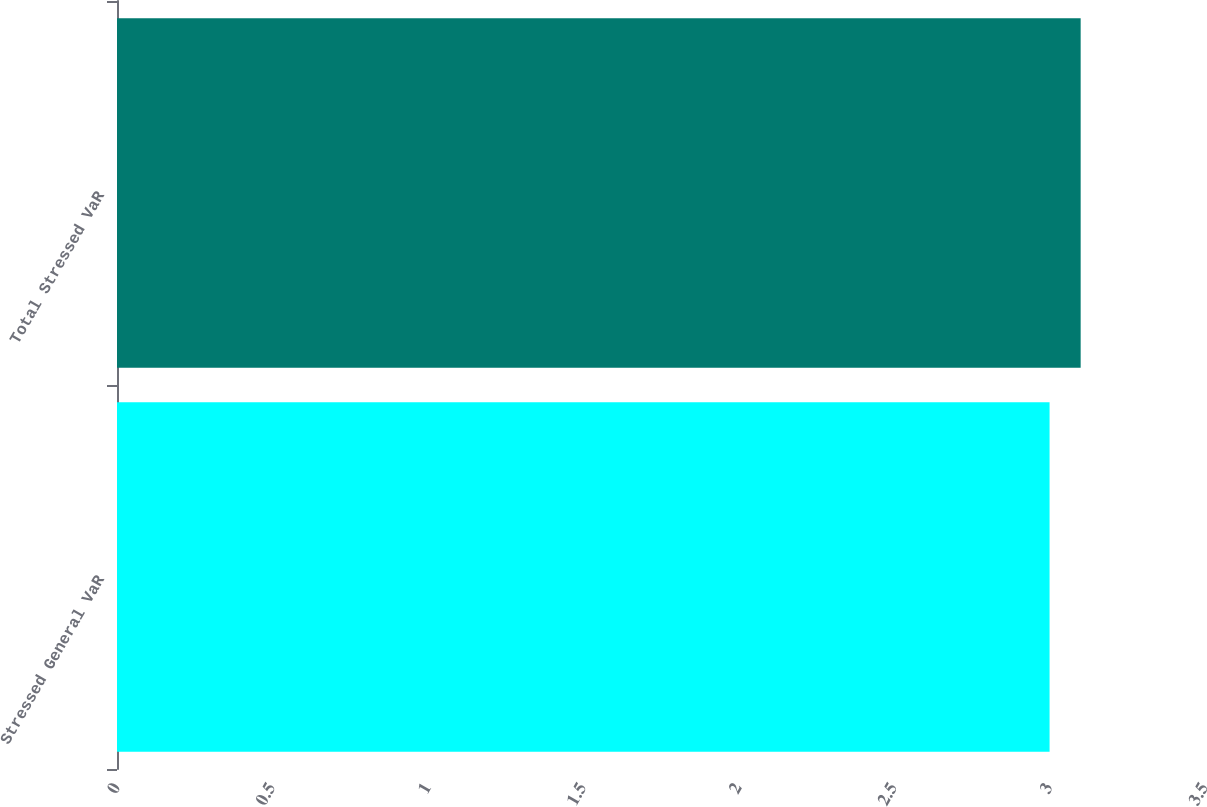Convert chart. <chart><loc_0><loc_0><loc_500><loc_500><bar_chart><fcel>Stressed General VaR<fcel>Total Stressed VaR<nl><fcel>3<fcel>3.1<nl></chart> 